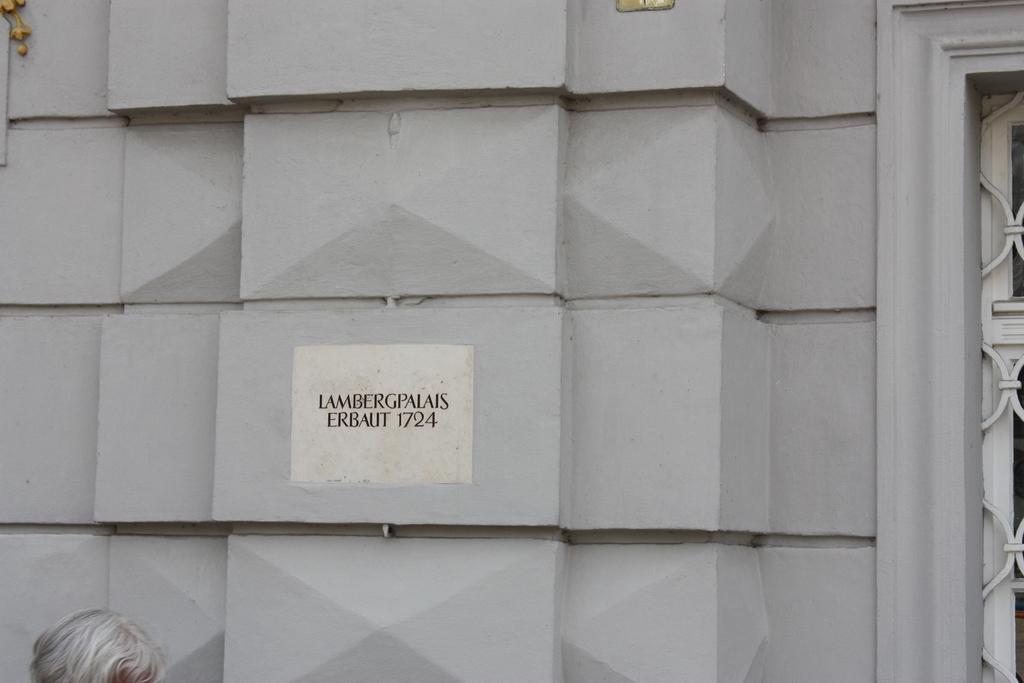How would you summarize this image in a sentence or two? In the foreground of this image, there is some text on the wall. On the right, it seems like a window. At the bottom, there is a head of a person. 